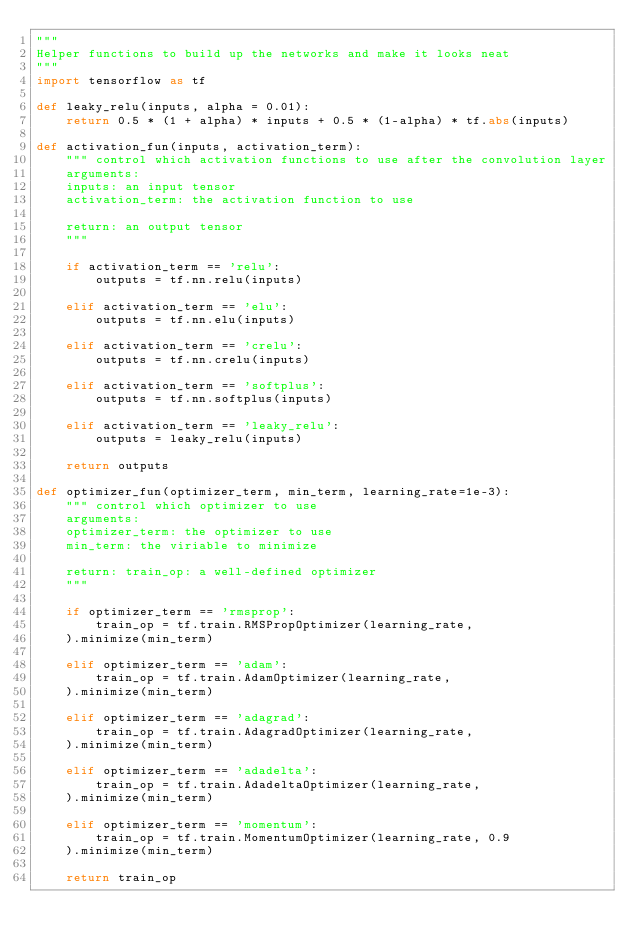Convert code to text. <code><loc_0><loc_0><loc_500><loc_500><_Python_>"""
Helper functions to build up the networks and make it looks neat
"""
import tensorflow as tf

def leaky_relu(inputs, alpha = 0.01):
    return 0.5 * (1 + alpha) * inputs + 0.5 * (1-alpha) * tf.abs(inputs)

def activation_fun(inputs, activation_term):
    """ control which activation functions to use after the convolution layer
    arguments: 
    inputs: an input tensor
    activation_term: the activation function to use
    
    return: an output tensor
    """
    
    if activation_term == 'relu':
        outputs = tf.nn.relu(inputs)
        
    elif activation_term == 'elu':
        outputs = tf.nn.elu(inputs)
        
    elif activation_term == 'crelu':
        outputs = tf.nn.crelu(inputs)
        
    elif activation_term == 'softplus':
        outputs = tf.nn.softplus(inputs)
        
    elif activation_term == 'leaky_relu':
        outputs = leaky_relu(inputs)
    
    return outputs

def optimizer_fun(optimizer_term, min_term, learning_rate=1e-3):
    """ control which optimizer to use 
    arguments: 
    optimizer_term: the optimizer to use
    min_term: the viriable to minimize
    
    return: train_op: a well-defined optimizer
    """
    
    if optimizer_term == 'rmsprop':
        train_op = tf.train.RMSPropOptimizer(learning_rate, 
    ).minimize(min_term)
        
    elif optimizer_term == 'adam':
        train_op = tf.train.AdamOptimizer(learning_rate, 
    ).minimize(min_term)
    
    elif optimizer_term == 'adagrad':
        train_op = tf.train.AdagradOptimizer(learning_rate, 
    ).minimize(min_term)
        
    elif optimizer_term == 'adadelta':
        train_op = tf.train.AdadeltaOptimizer(learning_rate, 
    ).minimize(min_term)
    
    elif optimizer_term == 'momentum':
        train_op = tf.train.MomentumOptimizer(learning_rate, 0.9
    ).minimize(min_term)
    
    return train_op</code> 